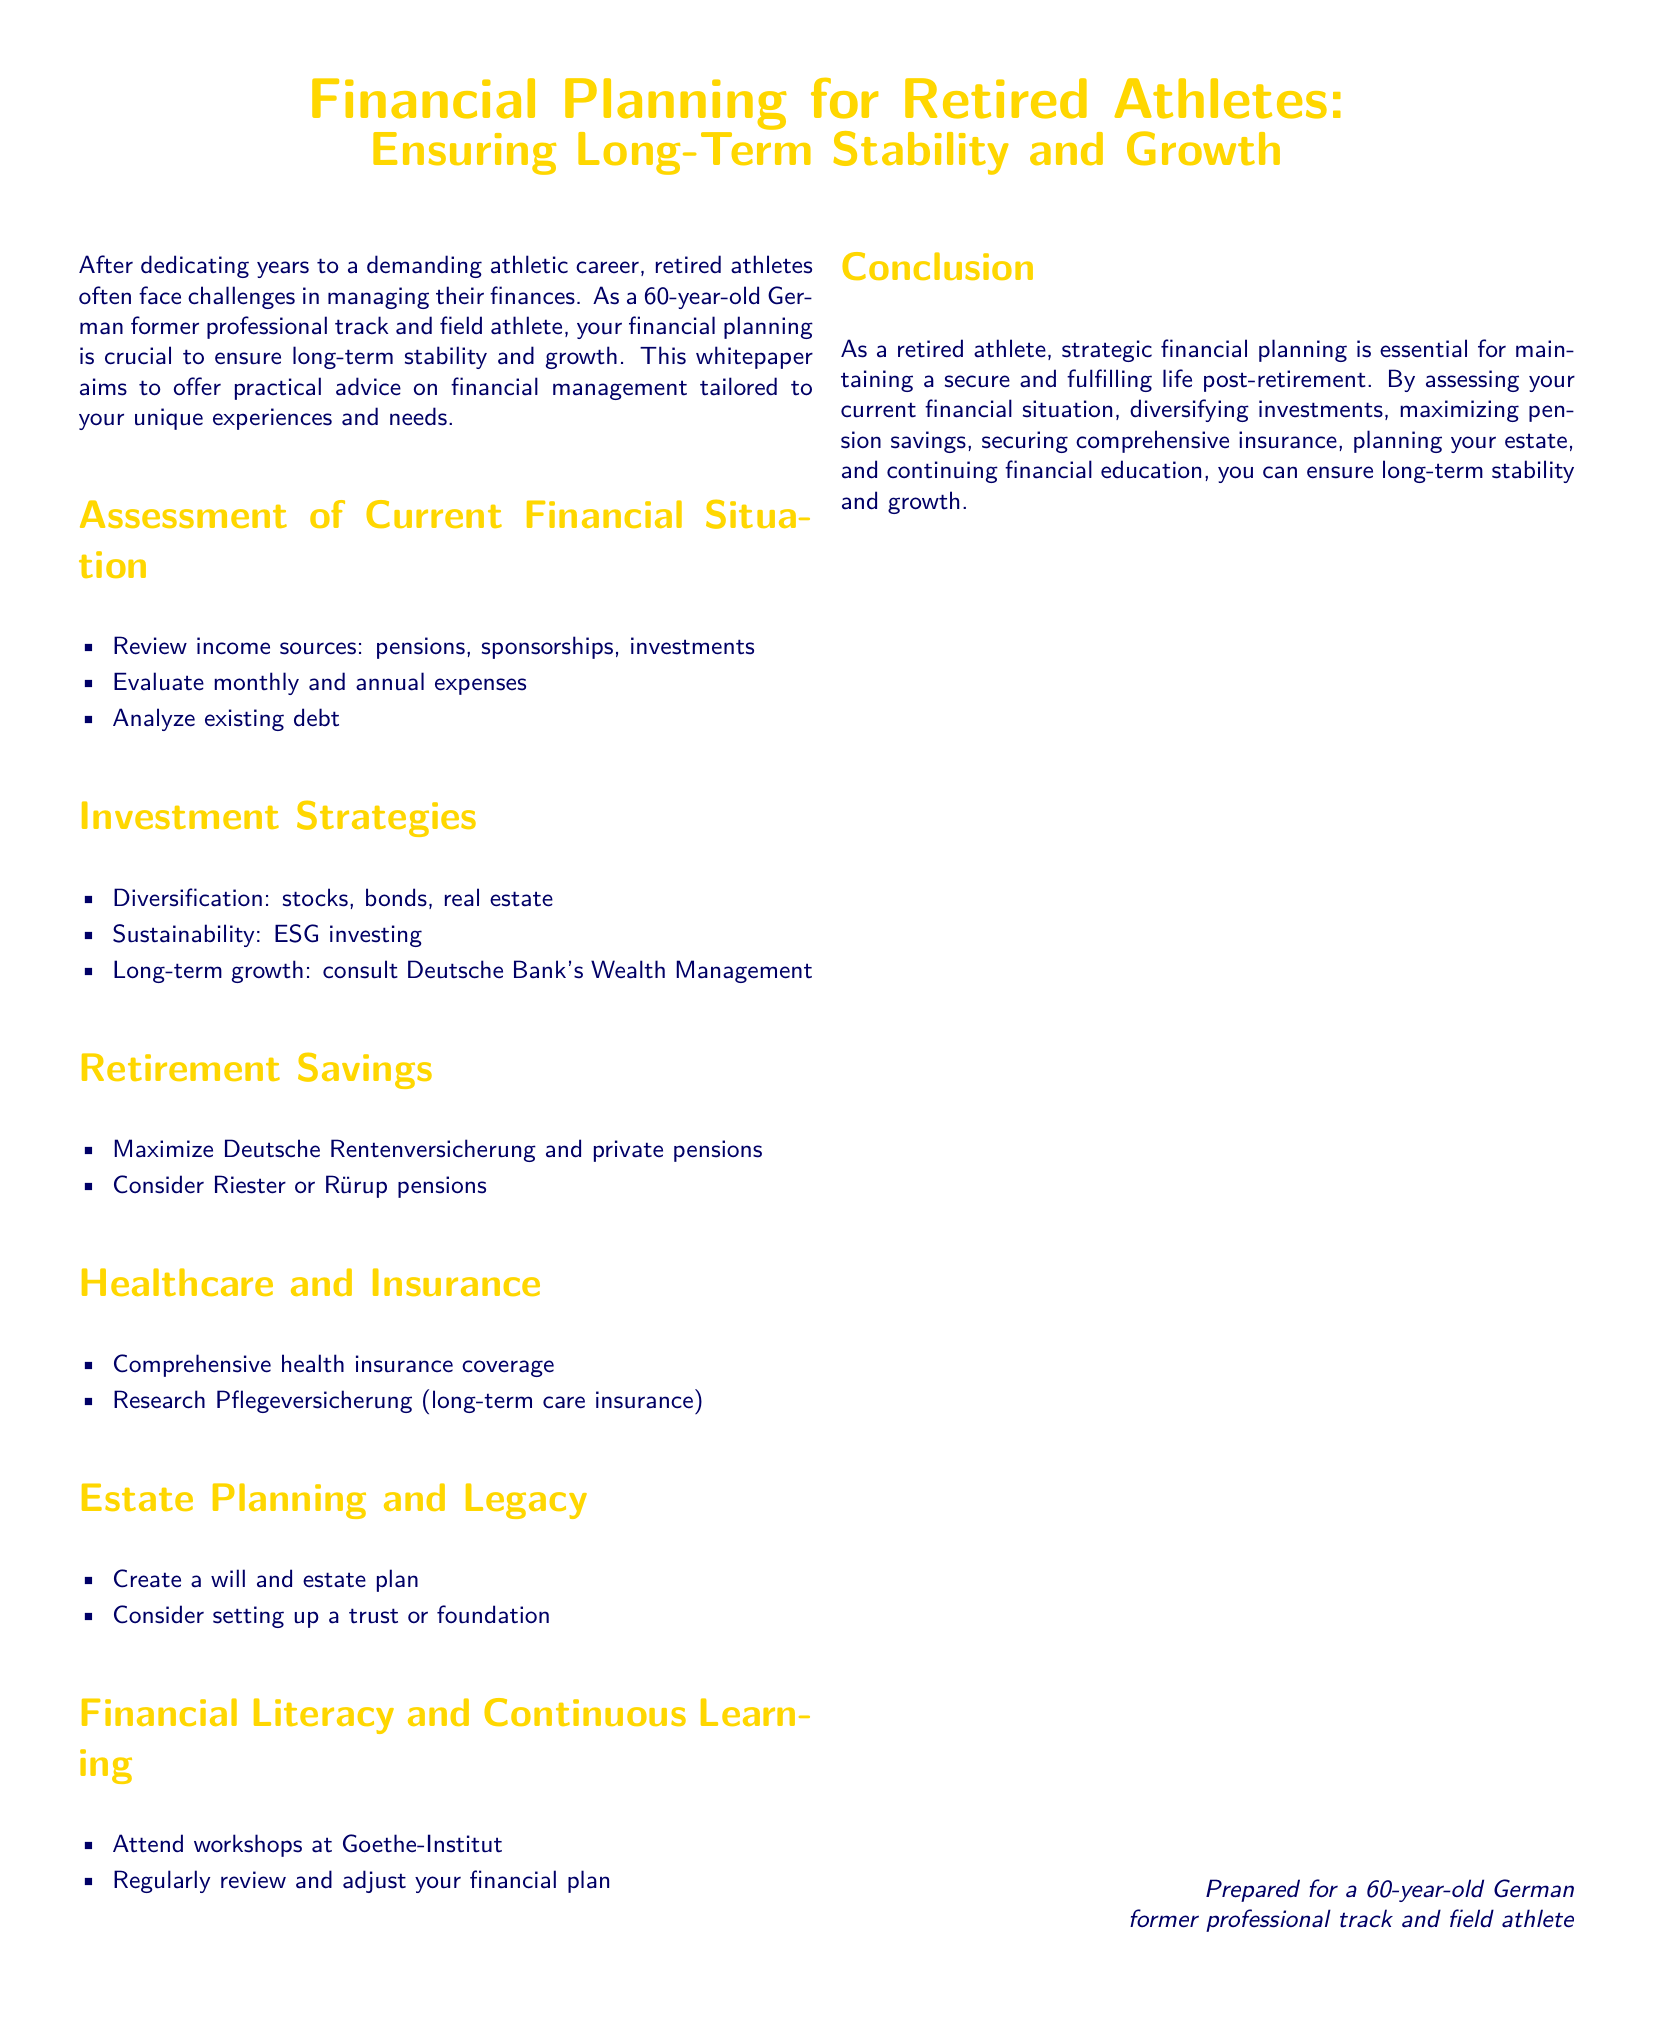What is the main focus of the whitepaper? The main focus is on providing practical advice for financial management tailored to retired athletes.
Answer: Financial Planning for Retired Athletes What are the investment strategies mentioned in the document? The document lists diversification, sustainability, and long-term growth as investment strategies.
Answer: Diversification, sustainability, long-term growth What should retired athletes maximize according to the retirement savings section? The section advises maximizing Deutsche Rentenversicherung and private pensions for financial security.
Answer: Deutsche Rentenversicherung and private pensions What kind of insurance is recommended in the healthcare section? The document encourages securing comprehensive health insurance coverage for retired athletes.
Answer: Comprehensive health insurance What is a suggested method for estate planning in the whitepaper? The document suggests creating a will and estate plan as part of estate planning.
Answer: Create a will and estate plan What institution is mentioned for workshops on financial literacy? The Goethe-Institut is identified as a place to attend workshops for financial learning.
Answer: Goethe-Institut What type of insurance is advised for long-term care? The document discusses researching Pflegeversicherung as a suitable insurance for long-term care.
Answer: Pflegeversicherung What does the conclusion emphasize as essential for retired athletes? The conclusion emphasizes the importance of strategic financial planning for a secure post-retirement life.
Answer: Strategic financial planning Why is financial literacy important according to the whitepaper? Financial literacy is important for regular reviews and adjustments of the financial plan.
Answer: Regular reviews and adjustments of the financial plan 